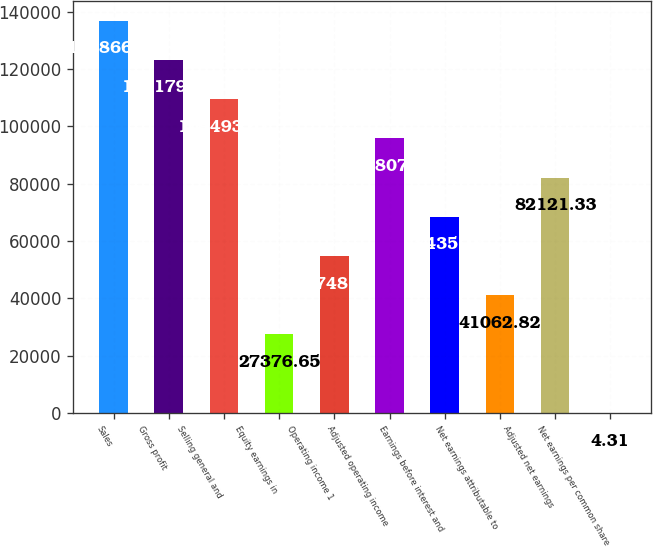Convert chart. <chart><loc_0><loc_0><loc_500><loc_500><bar_chart><fcel>Sales<fcel>Gross profit<fcel>Selling general and<fcel>Equity earnings in<fcel>Operating income 1<fcel>Adjusted operating income<fcel>Earnings before interest and<fcel>Net earnings attributable to<fcel>Adjusted net earnings<fcel>Net earnings per common share<nl><fcel>136866<fcel>123180<fcel>109494<fcel>27376.7<fcel>54749<fcel>95807.5<fcel>68435.2<fcel>41062.8<fcel>82121.3<fcel>4.31<nl></chart> 